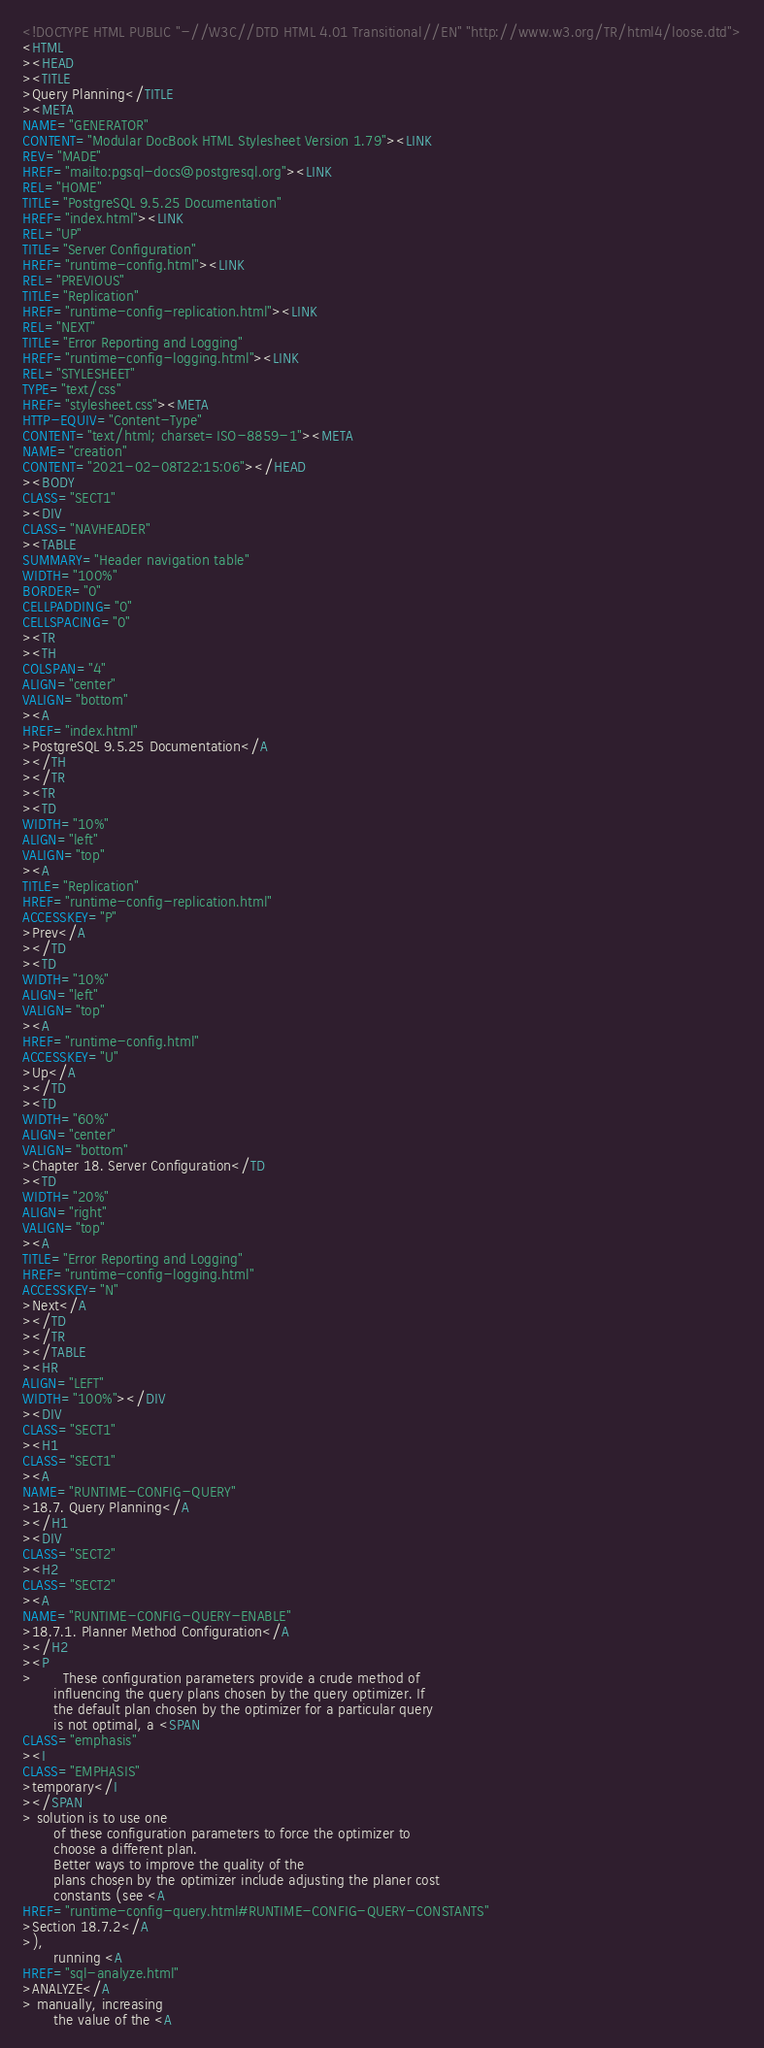Convert code to text. <code><loc_0><loc_0><loc_500><loc_500><_HTML_><!DOCTYPE HTML PUBLIC "-//W3C//DTD HTML 4.01 Transitional//EN" "http://www.w3.org/TR/html4/loose.dtd">
<HTML
><HEAD
><TITLE
>Query Planning</TITLE
><META
NAME="GENERATOR"
CONTENT="Modular DocBook HTML Stylesheet Version 1.79"><LINK
REV="MADE"
HREF="mailto:pgsql-docs@postgresql.org"><LINK
REL="HOME"
TITLE="PostgreSQL 9.5.25 Documentation"
HREF="index.html"><LINK
REL="UP"
TITLE="Server Configuration"
HREF="runtime-config.html"><LINK
REL="PREVIOUS"
TITLE="Replication"
HREF="runtime-config-replication.html"><LINK
REL="NEXT"
TITLE="Error Reporting and Logging"
HREF="runtime-config-logging.html"><LINK
REL="STYLESHEET"
TYPE="text/css"
HREF="stylesheet.css"><META
HTTP-EQUIV="Content-Type"
CONTENT="text/html; charset=ISO-8859-1"><META
NAME="creation"
CONTENT="2021-02-08T22:15:06"></HEAD
><BODY
CLASS="SECT1"
><DIV
CLASS="NAVHEADER"
><TABLE
SUMMARY="Header navigation table"
WIDTH="100%"
BORDER="0"
CELLPADDING="0"
CELLSPACING="0"
><TR
><TH
COLSPAN="4"
ALIGN="center"
VALIGN="bottom"
><A
HREF="index.html"
>PostgreSQL 9.5.25 Documentation</A
></TH
></TR
><TR
><TD
WIDTH="10%"
ALIGN="left"
VALIGN="top"
><A
TITLE="Replication"
HREF="runtime-config-replication.html"
ACCESSKEY="P"
>Prev</A
></TD
><TD
WIDTH="10%"
ALIGN="left"
VALIGN="top"
><A
HREF="runtime-config.html"
ACCESSKEY="U"
>Up</A
></TD
><TD
WIDTH="60%"
ALIGN="center"
VALIGN="bottom"
>Chapter 18. Server Configuration</TD
><TD
WIDTH="20%"
ALIGN="right"
VALIGN="top"
><A
TITLE="Error Reporting and Logging"
HREF="runtime-config-logging.html"
ACCESSKEY="N"
>Next</A
></TD
></TR
></TABLE
><HR
ALIGN="LEFT"
WIDTH="100%"></DIV
><DIV
CLASS="SECT1"
><H1
CLASS="SECT1"
><A
NAME="RUNTIME-CONFIG-QUERY"
>18.7. Query Planning</A
></H1
><DIV
CLASS="SECT2"
><H2
CLASS="SECT2"
><A
NAME="RUNTIME-CONFIG-QUERY-ENABLE"
>18.7.1. Planner Method Configuration</A
></H2
><P
>       These configuration parameters provide a crude method of
       influencing the query plans chosen by the query optimizer. If
       the default plan chosen by the optimizer for a particular query
       is not optimal, a <SPAN
CLASS="emphasis"
><I
CLASS="EMPHASIS"
>temporary</I
></SPAN
> solution is to use one
       of these configuration parameters to force the optimizer to
       choose a different plan.
       Better ways to improve the quality of the
       plans chosen by the optimizer include adjusting the planer cost
       constants (see <A
HREF="runtime-config-query.html#RUNTIME-CONFIG-QUERY-CONSTANTS"
>Section 18.7.2</A
>),
       running <A
HREF="sql-analyze.html"
>ANALYZE</A
> manually, increasing
       the value of the <A</code> 